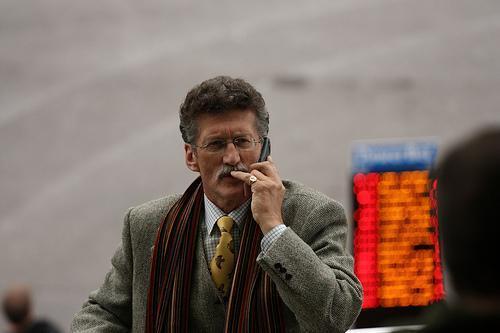How many rings does he have on?
Give a very brief answer. 1. How many phones does he have?
Give a very brief answer. 1. 